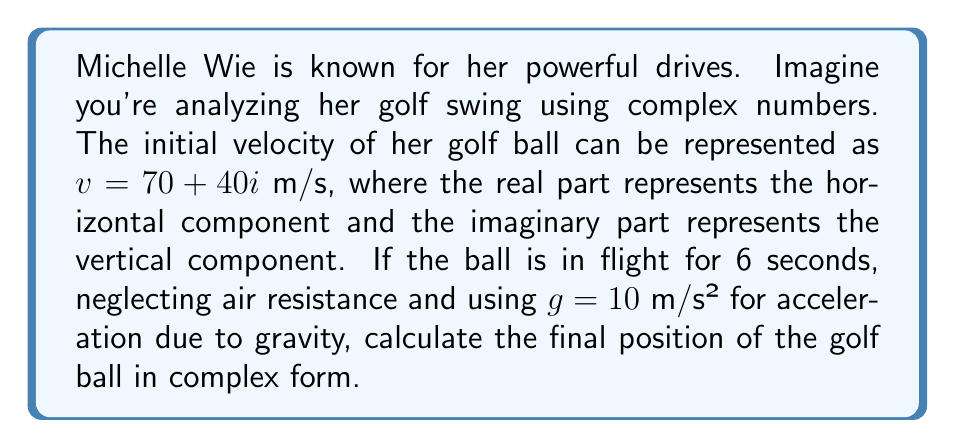Solve this math problem. To solve this problem, we'll use the complex number approach to represent the position of the golf ball. Let's break it down step by step:

1) The initial velocity is given as $v = 70 + 40i$ m/s.

2) We know that position in complex form can be represented as $z(t) = z_0 + vt + \frac{1}{2}at^2$, where:
   - $z_0$ is the initial position (in this case, $0 + 0i$ as we assume starting from the origin)
   - $v$ is the initial velocity
   - $a$ is the acceleration
   - $t$ is the time

3) The acceleration due to gravity acts only in the vertical (imaginary) direction and is negative: $a = 0 - 10i$ m/s²

4) Substituting these values into our equation:

   $$z(t) = (0 + 0i) + (70 + 40i)t + \frac{1}{2}(0 - 10i)t^2$$

5) Simplify:

   $$z(t) = (70 + 40i)t - 5it^2$$

6) Now, we need to calculate this for $t = 6$ seconds:

   $$z(6) = (70 + 40i)(6) - 5i(6^2)$$

7) Simplify:

   $$z(6) = (420 + 240i) - 180i$$
   $$z(6) = 420 + 60i$$

Therefore, after 6 seconds, the golf ball's position can be represented by the complex number $420 + 60i$.
Answer: $420 + 60i$ meters 